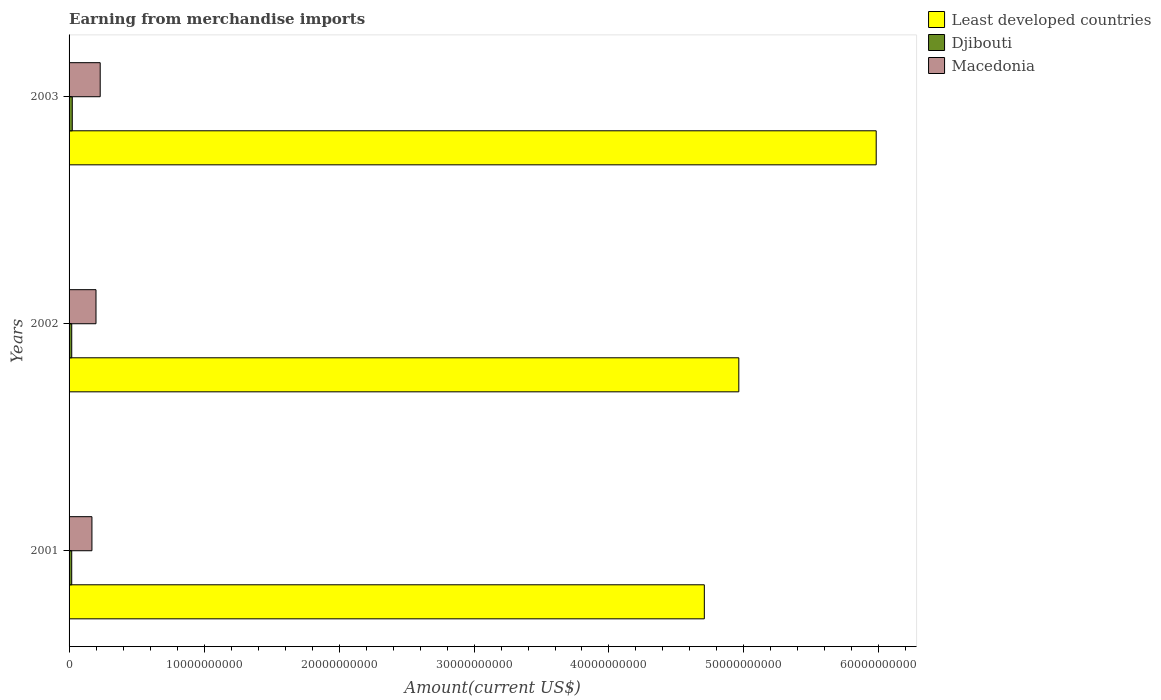How many different coloured bars are there?
Make the answer very short. 3. Are the number of bars per tick equal to the number of legend labels?
Give a very brief answer. Yes. How many bars are there on the 1st tick from the top?
Your response must be concise. 3. What is the label of the 2nd group of bars from the top?
Give a very brief answer. 2002. In how many cases, is the number of bars for a given year not equal to the number of legend labels?
Provide a succinct answer. 0. What is the amount earned from merchandise imports in Macedonia in 2001?
Make the answer very short. 1.69e+09. Across all years, what is the maximum amount earned from merchandise imports in Least developed countries?
Provide a succinct answer. 5.98e+1. Across all years, what is the minimum amount earned from merchandise imports in Macedonia?
Provide a short and direct response. 1.69e+09. In which year was the amount earned from merchandise imports in Least developed countries maximum?
Your answer should be compact. 2003. In which year was the amount earned from merchandise imports in Macedonia minimum?
Offer a very short reply. 2001. What is the total amount earned from merchandise imports in Djibouti in the graph?
Provide a succinct answer. 6.31e+08. What is the difference between the amount earned from merchandise imports in Djibouti in 2001 and that in 2002?
Make the answer very short. -1.06e+06. What is the difference between the amount earned from merchandise imports in Least developed countries in 2003 and the amount earned from merchandise imports in Macedonia in 2002?
Your response must be concise. 5.78e+1. What is the average amount earned from merchandise imports in Macedonia per year?
Your answer should be very brief. 2.00e+09. In the year 2002, what is the difference between the amount earned from merchandise imports in Macedonia and amount earned from merchandise imports in Djibouti?
Make the answer very short. 1.80e+09. What is the ratio of the amount earned from merchandise imports in Djibouti in 2002 to that in 2003?
Give a very brief answer. 0.83. Is the amount earned from merchandise imports in Least developed countries in 2001 less than that in 2003?
Offer a very short reply. Yes. What is the difference between the highest and the second highest amount earned from merchandise imports in Macedonia?
Give a very brief answer. 3.11e+08. What is the difference between the highest and the lowest amount earned from merchandise imports in Macedonia?
Ensure brevity in your answer.  6.12e+08. What does the 1st bar from the top in 2002 represents?
Your answer should be compact. Macedonia. What does the 1st bar from the bottom in 2002 represents?
Your answer should be compact. Least developed countries. How many bars are there?
Make the answer very short. 9. What is the difference between two consecutive major ticks on the X-axis?
Your answer should be very brief. 1.00e+1. Does the graph contain grids?
Offer a terse response. No. Where does the legend appear in the graph?
Your answer should be very brief. Top right. What is the title of the graph?
Your response must be concise. Earning from merchandise imports. What is the label or title of the X-axis?
Give a very brief answer. Amount(current US$). What is the Amount(current US$) of Least developed countries in 2001?
Your answer should be very brief. 4.71e+1. What is the Amount(current US$) in Djibouti in 2001?
Provide a succinct answer. 1.96e+08. What is the Amount(current US$) of Macedonia in 2001?
Ensure brevity in your answer.  1.69e+09. What is the Amount(current US$) of Least developed countries in 2002?
Offer a terse response. 4.96e+1. What is the Amount(current US$) in Djibouti in 2002?
Give a very brief answer. 1.97e+08. What is the Amount(current US$) in Macedonia in 2002?
Make the answer very short. 2.00e+09. What is the Amount(current US$) of Least developed countries in 2003?
Offer a very short reply. 5.98e+1. What is the Amount(current US$) of Djibouti in 2003?
Your answer should be very brief. 2.38e+08. What is the Amount(current US$) in Macedonia in 2003?
Offer a very short reply. 2.31e+09. Across all years, what is the maximum Amount(current US$) of Least developed countries?
Make the answer very short. 5.98e+1. Across all years, what is the maximum Amount(current US$) in Djibouti?
Ensure brevity in your answer.  2.38e+08. Across all years, what is the maximum Amount(current US$) in Macedonia?
Give a very brief answer. 2.31e+09. Across all years, what is the minimum Amount(current US$) of Least developed countries?
Keep it short and to the point. 4.71e+1. Across all years, what is the minimum Amount(current US$) of Djibouti?
Your answer should be compact. 1.96e+08. Across all years, what is the minimum Amount(current US$) in Macedonia?
Offer a terse response. 1.69e+09. What is the total Amount(current US$) of Least developed countries in the graph?
Your answer should be compact. 1.56e+11. What is the total Amount(current US$) in Djibouti in the graph?
Your answer should be compact. 6.31e+08. What is the total Amount(current US$) of Macedonia in the graph?
Provide a short and direct response. 6.00e+09. What is the difference between the Amount(current US$) in Least developed countries in 2001 and that in 2002?
Your answer should be compact. -2.55e+09. What is the difference between the Amount(current US$) in Djibouti in 2001 and that in 2002?
Your response must be concise. -1.06e+06. What is the difference between the Amount(current US$) in Macedonia in 2001 and that in 2002?
Ensure brevity in your answer.  -3.01e+08. What is the difference between the Amount(current US$) in Least developed countries in 2001 and that in 2003?
Make the answer very short. -1.27e+1. What is the difference between the Amount(current US$) in Djibouti in 2001 and that in 2003?
Keep it short and to the point. -4.22e+07. What is the difference between the Amount(current US$) of Macedonia in 2001 and that in 2003?
Your answer should be very brief. -6.12e+08. What is the difference between the Amount(current US$) in Least developed countries in 2002 and that in 2003?
Provide a succinct answer. -1.02e+1. What is the difference between the Amount(current US$) in Djibouti in 2002 and that in 2003?
Your response must be concise. -4.12e+07. What is the difference between the Amount(current US$) in Macedonia in 2002 and that in 2003?
Your response must be concise. -3.11e+08. What is the difference between the Amount(current US$) of Least developed countries in 2001 and the Amount(current US$) of Djibouti in 2002?
Offer a very short reply. 4.69e+1. What is the difference between the Amount(current US$) in Least developed countries in 2001 and the Amount(current US$) in Macedonia in 2002?
Provide a succinct answer. 4.51e+1. What is the difference between the Amount(current US$) of Djibouti in 2001 and the Amount(current US$) of Macedonia in 2002?
Your answer should be compact. -1.80e+09. What is the difference between the Amount(current US$) in Least developed countries in 2001 and the Amount(current US$) in Djibouti in 2003?
Your answer should be very brief. 4.68e+1. What is the difference between the Amount(current US$) in Least developed countries in 2001 and the Amount(current US$) in Macedonia in 2003?
Make the answer very short. 4.48e+1. What is the difference between the Amount(current US$) in Djibouti in 2001 and the Amount(current US$) in Macedonia in 2003?
Ensure brevity in your answer.  -2.11e+09. What is the difference between the Amount(current US$) in Least developed countries in 2002 and the Amount(current US$) in Djibouti in 2003?
Offer a very short reply. 4.94e+1. What is the difference between the Amount(current US$) of Least developed countries in 2002 and the Amount(current US$) of Macedonia in 2003?
Provide a succinct answer. 4.73e+1. What is the difference between the Amount(current US$) of Djibouti in 2002 and the Amount(current US$) of Macedonia in 2003?
Ensure brevity in your answer.  -2.11e+09. What is the average Amount(current US$) in Least developed countries per year?
Keep it short and to the point. 5.22e+1. What is the average Amount(current US$) in Djibouti per year?
Offer a very short reply. 2.10e+08. What is the average Amount(current US$) in Macedonia per year?
Provide a succinct answer. 2.00e+09. In the year 2001, what is the difference between the Amount(current US$) of Least developed countries and Amount(current US$) of Djibouti?
Offer a terse response. 4.69e+1. In the year 2001, what is the difference between the Amount(current US$) in Least developed countries and Amount(current US$) in Macedonia?
Keep it short and to the point. 4.54e+1. In the year 2001, what is the difference between the Amount(current US$) of Djibouti and Amount(current US$) of Macedonia?
Ensure brevity in your answer.  -1.50e+09. In the year 2002, what is the difference between the Amount(current US$) of Least developed countries and Amount(current US$) of Djibouti?
Offer a very short reply. 4.94e+1. In the year 2002, what is the difference between the Amount(current US$) in Least developed countries and Amount(current US$) in Macedonia?
Ensure brevity in your answer.  4.76e+1. In the year 2002, what is the difference between the Amount(current US$) of Djibouti and Amount(current US$) of Macedonia?
Offer a terse response. -1.80e+09. In the year 2003, what is the difference between the Amount(current US$) of Least developed countries and Amount(current US$) of Djibouti?
Offer a very short reply. 5.96e+1. In the year 2003, what is the difference between the Amount(current US$) of Least developed countries and Amount(current US$) of Macedonia?
Provide a succinct answer. 5.75e+1. In the year 2003, what is the difference between the Amount(current US$) in Djibouti and Amount(current US$) in Macedonia?
Your response must be concise. -2.07e+09. What is the ratio of the Amount(current US$) of Least developed countries in 2001 to that in 2002?
Provide a succinct answer. 0.95. What is the ratio of the Amount(current US$) of Macedonia in 2001 to that in 2002?
Your answer should be compact. 0.85. What is the ratio of the Amount(current US$) of Least developed countries in 2001 to that in 2003?
Keep it short and to the point. 0.79. What is the ratio of the Amount(current US$) in Djibouti in 2001 to that in 2003?
Provide a short and direct response. 0.82. What is the ratio of the Amount(current US$) in Macedonia in 2001 to that in 2003?
Keep it short and to the point. 0.73. What is the ratio of the Amount(current US$) of Least developed countries in 2002 to that in 2003?
Make the answer very short. 0.83. What is the ratio of the Amount(current US$) in Djibouti in 2002 to that in 2003?
Your answer should be very brief. 0.83. What is the ratio of the Amount(current US$) in Macedonia in 2002 to that in 2003?
Your answer should be compact. 0.87. What is the difference between the highest and the second highest Amount(current US$) of Least developed countries?
Your answer should be compact. 1.02e+1. What is the difference between the highest and the second highest Amount(current US$) in Djibouti?
Your answer should be compact. 4.12e+07. What is the difference between the highest and the second highest Amount(current US$) of Macedonia?
Your answer should be very brief. 3.11e+08. What is the difference between the highest and the lowest Amount(current US$) in Least developed countries?
Provide a short and direct response. 1.27e+1. What is the difference between the highest and the lowest Amount(current US$) in Djibouti?
Give a very brief answer. 4.22e+07. What is the difference between the highest and the lowest Amount(current US$) in Macedonia?
Offer a terse response. 6.12e+08. 